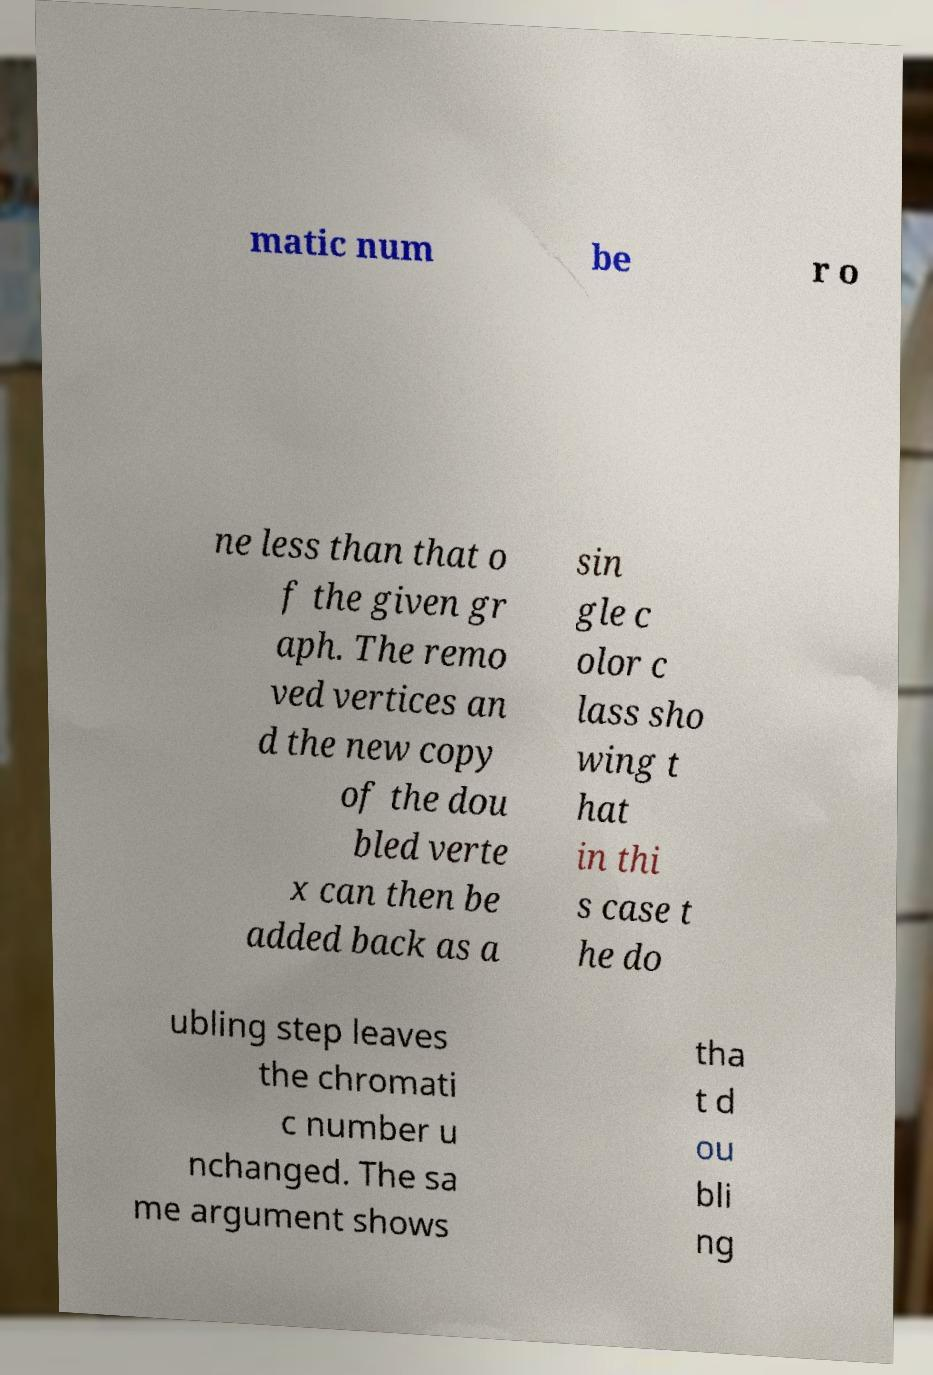Please read and relay the text visible in this image. What does it say? matic num be r o ne less than that o f the given gr aph. The remo ved vertices an d the new copy of the dou bled verte x can then be added back as a sin gle c olor c lass sho wing t hat in thi s case t he do ubling step leaves the chromati c number u nchanged. The sa me argument shows tha t d ou bli ng 